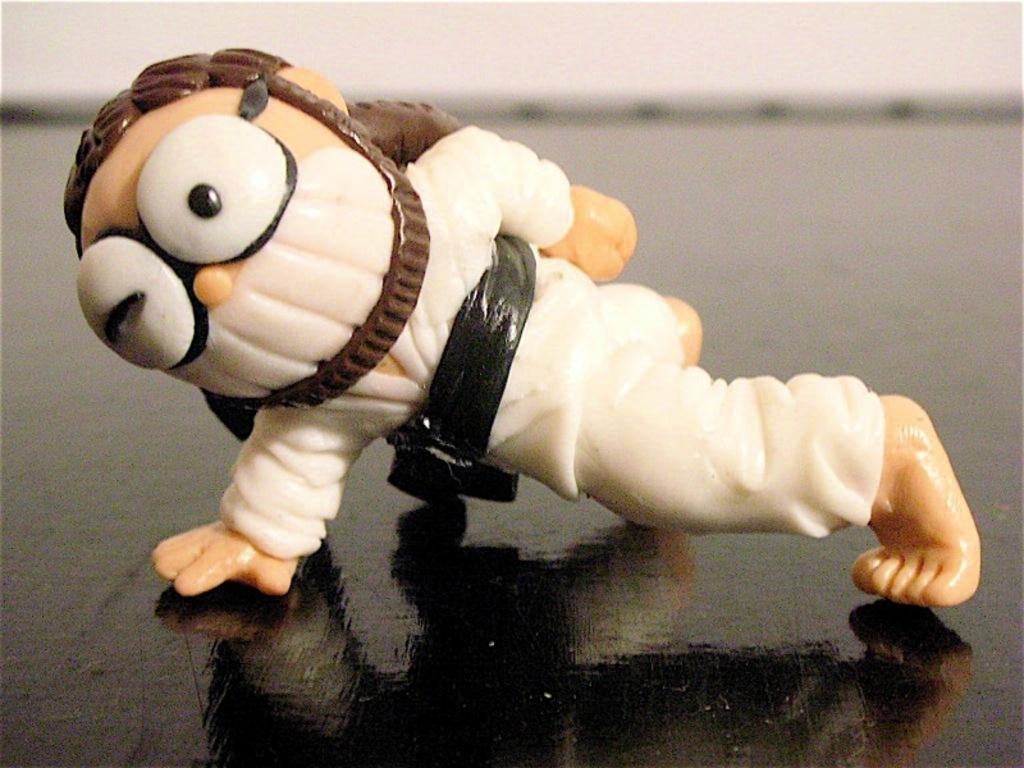What is the main subject in the image? There is a figure in the image. Where is the figure located? The figure is placed on a table. What type of field can be seen in the image? There is no field present in the image; it only features a figure placed on a table. Is the milk hot or cold in the image? There is no mention of milk in the image, so it cannot be determined if it is hot or cold. 